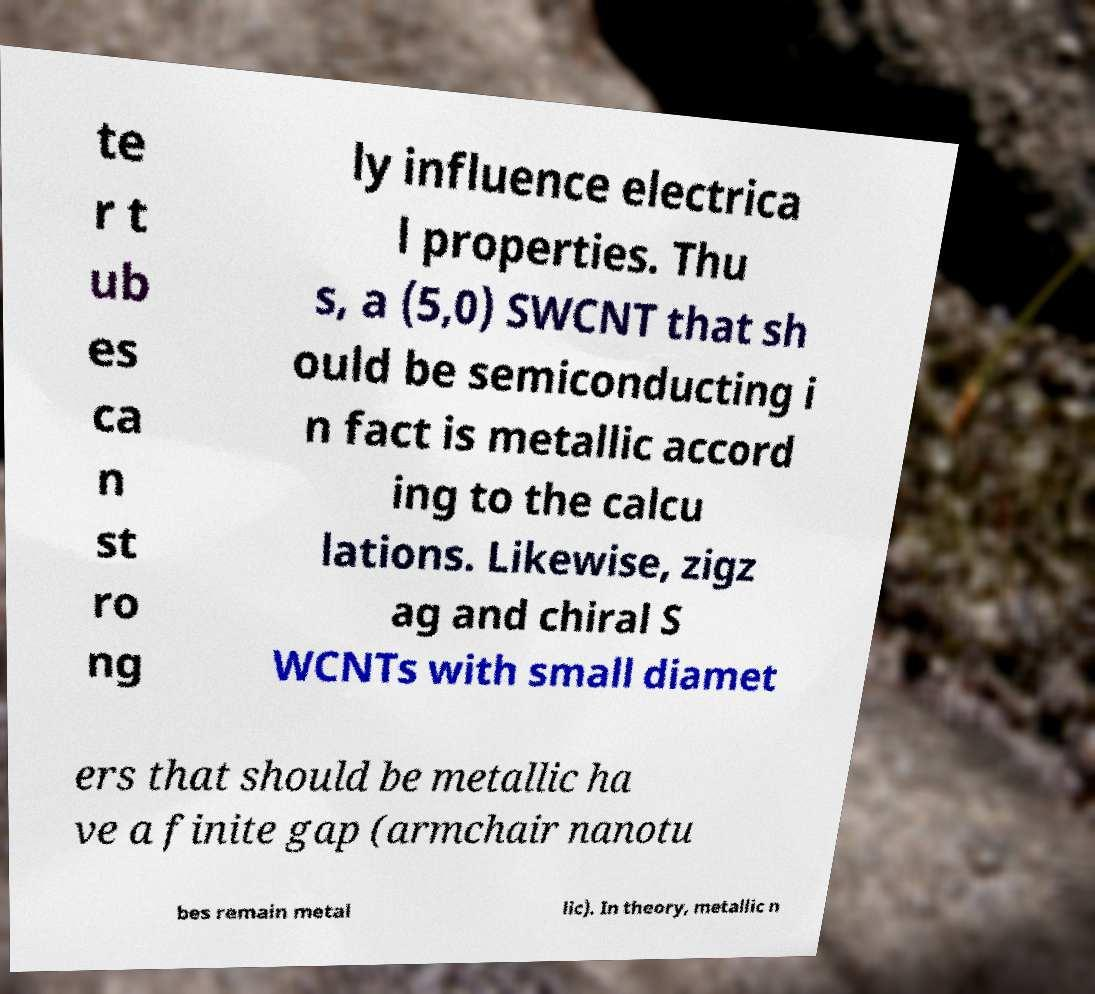For documentation purposes, I need the text within this image transcribed. Could you provide that? te r t ub es ca n st ro ng ly influence electrica l properties. Thu s, a (5,0) SWCNT that sh ould be semiconducting i n fact is metallic accord ing to the calcu lations. Likewise, zigz ag and chiral S WCNTs with small diamet ers that should be metallic ha ve a finite gap (armchair nanotu bes remain metal lic). In theory, metallic n 